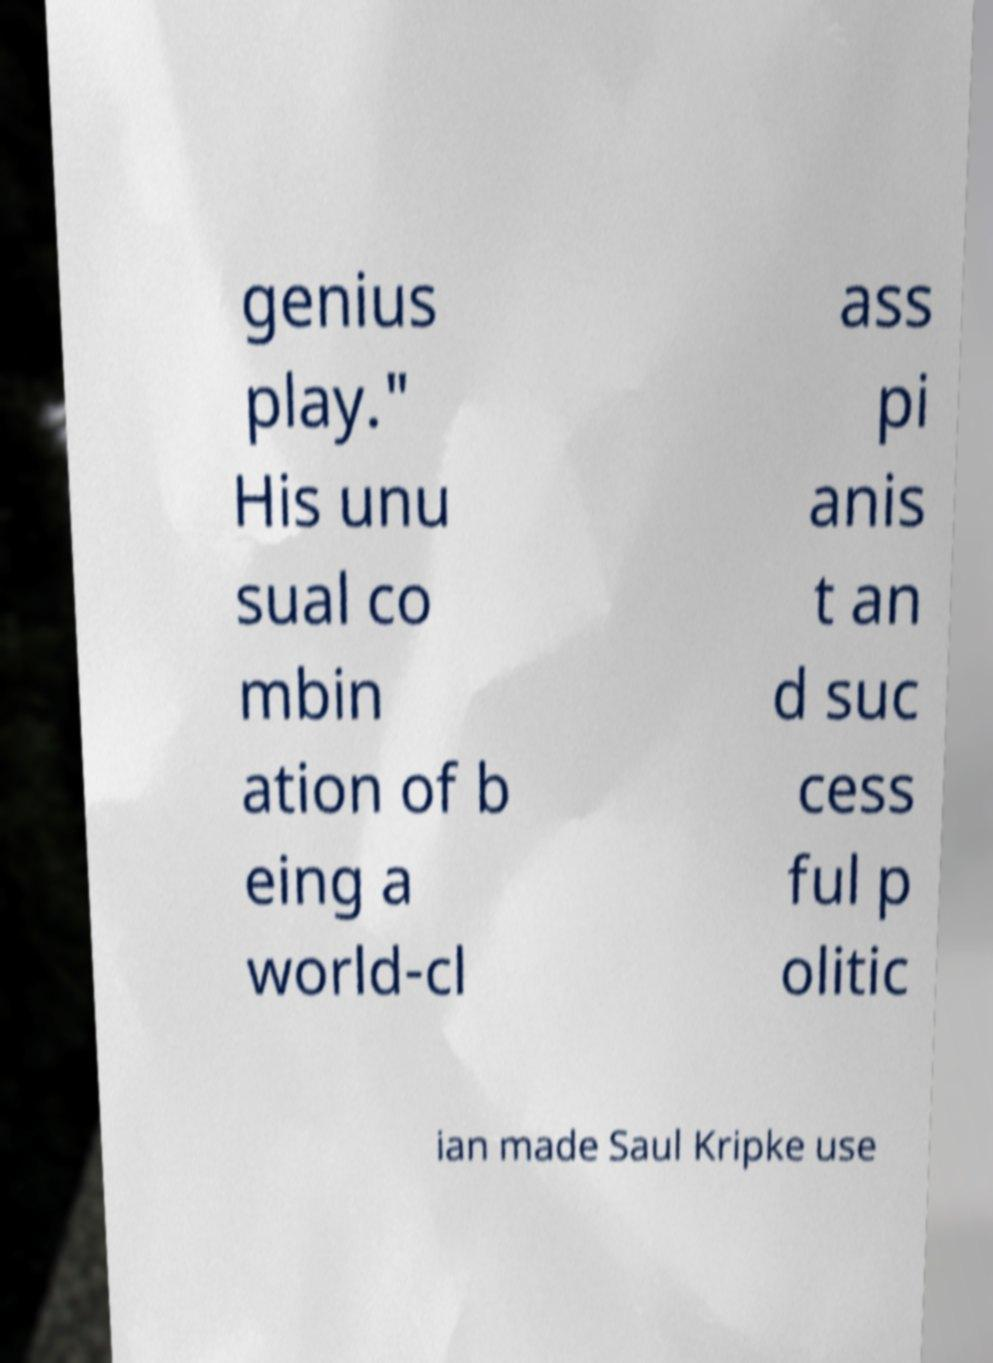Could you assist in decoding the text presented in this image and type it out clearly? genius play." His unu sual co mbin ation of b eing a world-cl ass pi anis t an d suc cess ful p olitic ian made Saul Kripke use 